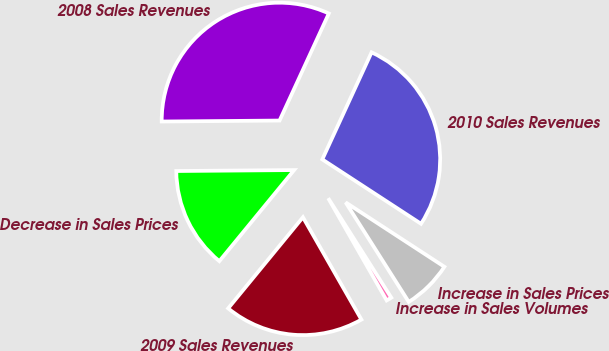Convert chart to OTSL. <chart><loc_0><loc_0><loc_500><loc_500><pie_chart><fcel>2008 Sales Revenues<fcel>Decrease in Sales Prices<fcel>2009 Sales Revenues<fcel>Increase in Sales Volumes<fcel>Increase in Sales Prices<fcel>2010 Sales Revenues<nl><fcel>31.99%<fcel>13.93%<fcel>19.2%<fcel>0.73%<fcel>6.81%<fcel>27.33%<nl></chart> 